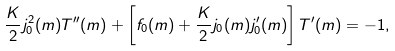<formula> <loc_0><loc_0><loc_500><loc_500>\frac { K } { 2 } j ^ { 2 } _ { 0 } ( m ) T ^ { \prime \prime } ( m ) + \left [ f _ { 0 } ( m ) + \frac { K } { 2 } j _ { 0 } ( m ) j ^ { \prime } _ { 0 } ( m ) \right ] T ^ { \prime } ( m ) = - 1 ,</formula> 